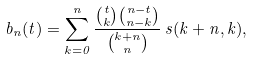Convert formula to latex. <formula><loc_0><loc_0><loc_500><loc_500>b _ { n } ( t ) = \sum _ { k = 0 } ^ { n } \frac { \binom { t } { k } \binom { n - t } { n - k } } { \binom { k + n } { n } } \, s ( k + n , k ) ,</formula> 